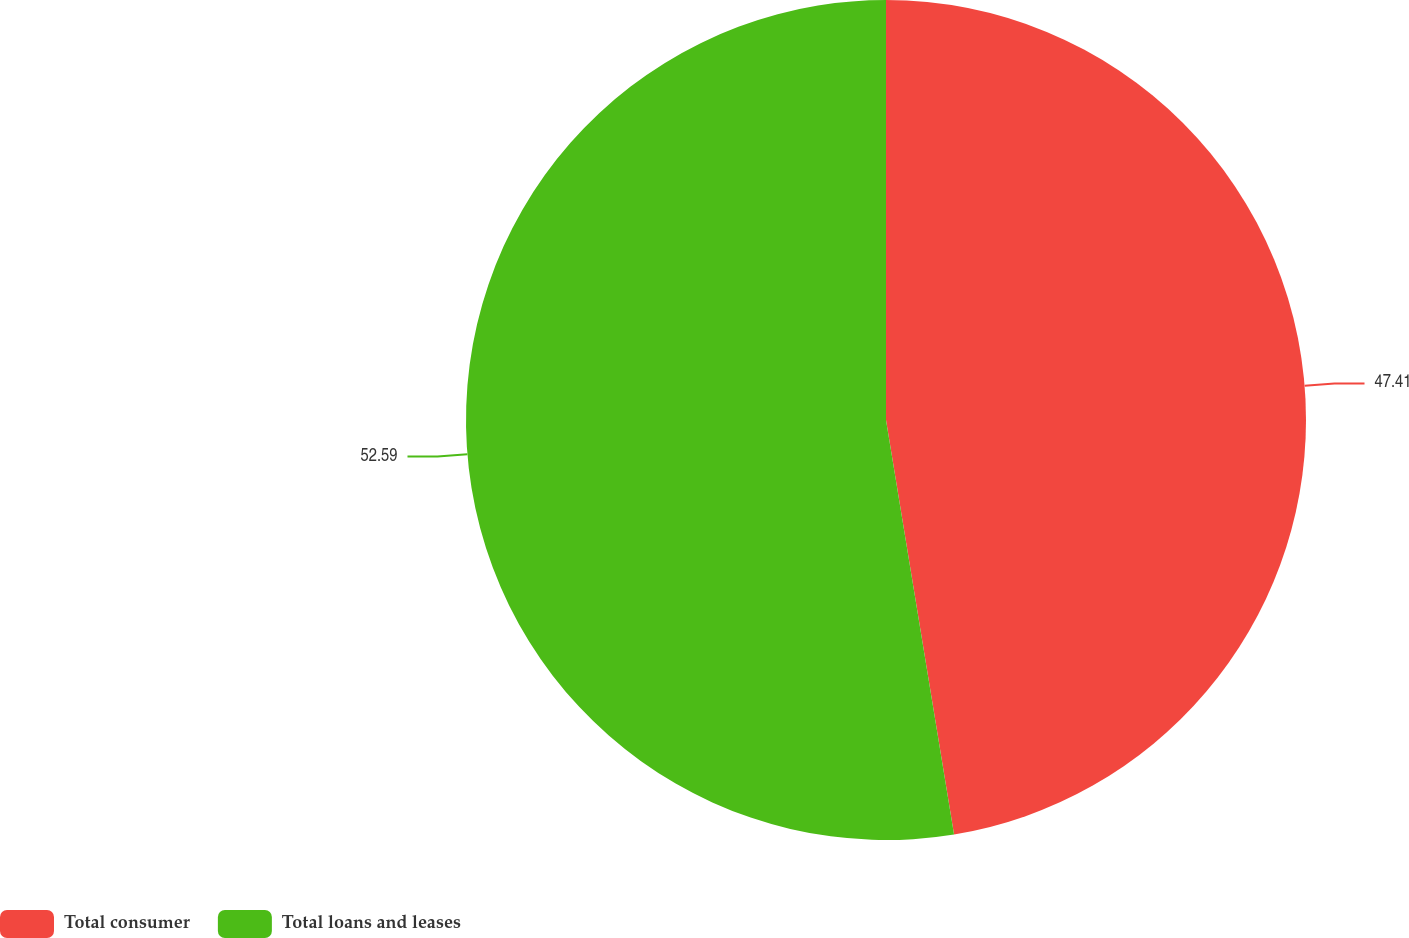<chart> <loc_0><loc_0><loc_500><loc_500><pie_chart><fcel>Total consumer<fcel>Total loans and leases<nl><fcel>47.41%<fcel>52.59%<nl></chart> 